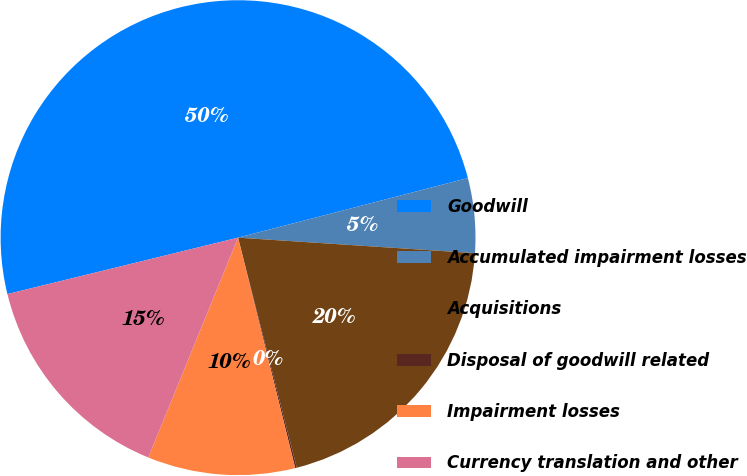<chart> <loc_0><loc_0><loc_500><loc_500><pie_chart><fcel>Goodwill<fcel>Accumulated impairment losses<fcel>Acquisitions<fcel>Disposal of goodwill related<fcel>Impairment losses<fcel>Currency translation and other<nl><fcel>49.78%<fcel>5.08%<fcel>19.98%<fcel>0.11%<fcel>10.04%<fcel>15.01%<nl></chart> 